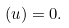<formula> <loc_0><loc_0><loc_500><loc_500>( u ) = 0 .</formula> 